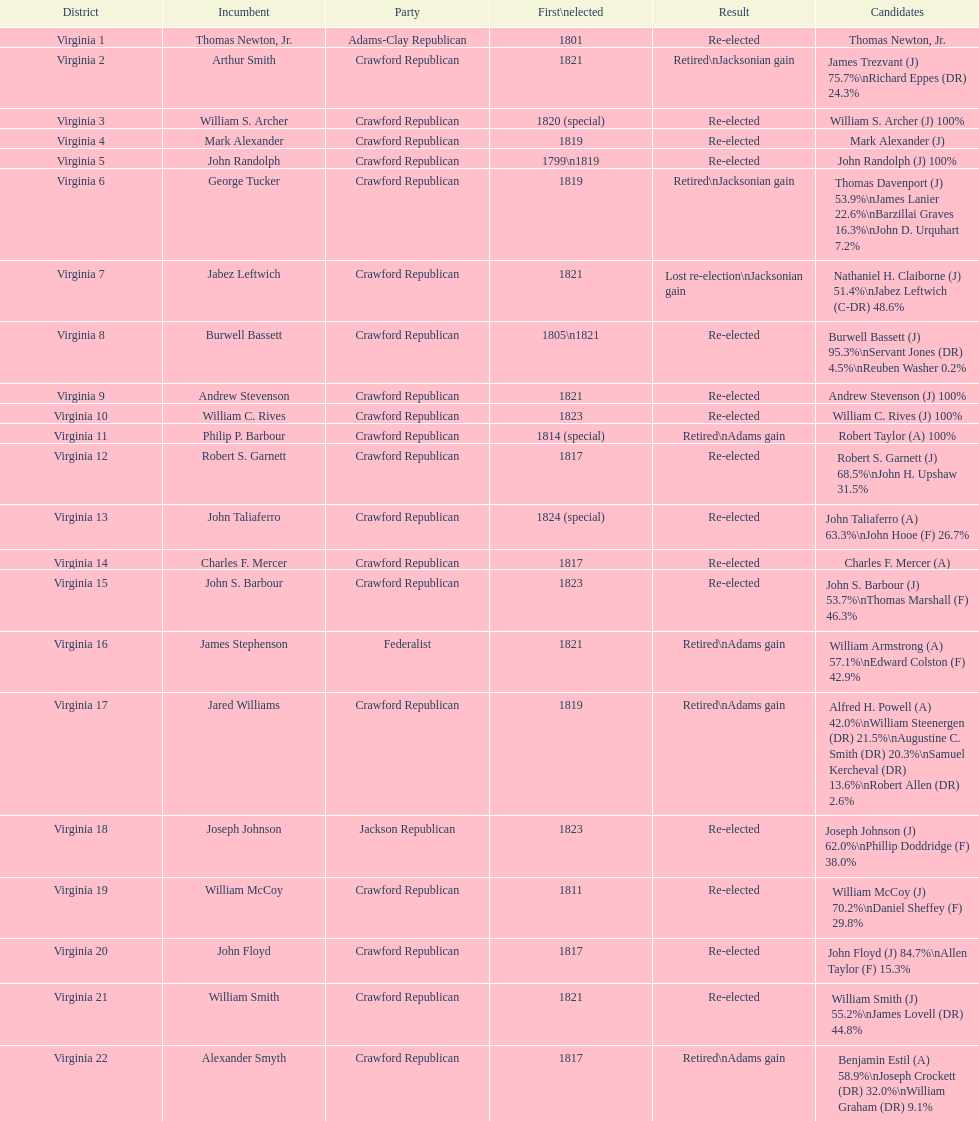Who was the one and only candidate elected for the first time in 1811? William McCoy. 